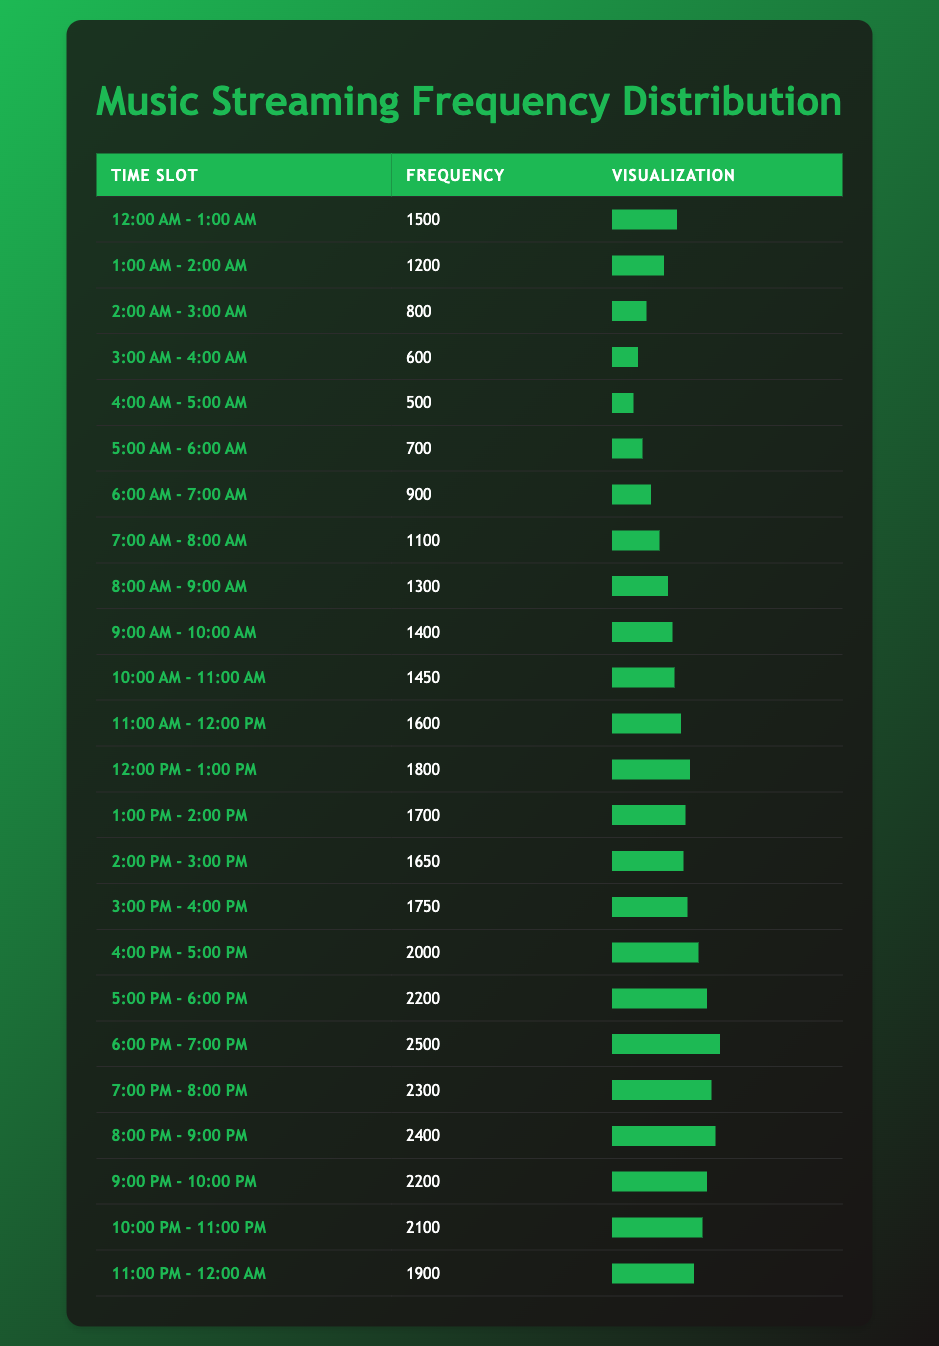What time slot had the highest frequency of streaming? By scanning the frequency data in the table, the time slot "6:00 PM - 7:00 PM" has the highest frequency with a value of 2500.
Answer: 6:00 PM - 7:00 PM What is the frequency of the time slot from 4:00 AM to 5:00 AM? In the table, the time slot "4:00 AM - 5:00 AM" shows a frequency of 500.
Answer: 500 What is the total frequency of streaming from 8:00 PM to 10:00 PM? First, we identify the frequencies in the time slots: "8:00 PM - 9:00 PM" has 2400, "9:00 PM - 10:00 PM" has 2200, and when we sum these values (2400 + 2200), we get 4600.
Answer: 4600 Is the frequency of the time slot from 10:00 PM to 11:00 PM greater than the frequency from 1:00 AM to 2:00 AM? The frequency for "10:00 PM - 11:00 PM" is 2100, and for "1:00 AM - 2:00 AM" it is 1200. Comparing these, 2100 is greater than 1200.
Answer: Yes What is the average frequency across the morning time slots from 12:00 AM to 12:00 PM? To find the average, I extract the frequencies from the relevant time slots: 1500, 1200, 800, 600, 500, 700, 900, 1100, 1300, 1400, 1450, 1600, 1800. I then sum these values, which equals 14050, and divide by the number of time slots (12) getting an average of approximately 1170.83.
Answer: 1170.83 Which time slot has a frequency between 600 and 800? The table shows that the time slot "3:00 AM - 4:00 AM" has a frequency of 600, and "2:00 AM - 3:00 AM" has a frequency of 800. Therefore, there is only one time slot that fits.
Answer: 3:00 AM - 4:00 AM How many more streams were there from the time slot 5:00 PM to 6:00 PM compared to the slot from 12:00 AM to 1:00 AM? From the table, the frequency for "5:00 PM - 6:00 PM" is 2200, and for "12:00 AM - 1:00 AM," it is 1500. The difference is calculated by subtracting the two rates: 2200 - 1500 = 700.
Answer: 700 What time slot comes before the one with the lowest frequency? The time slot with the lowest frequency is "4:00 AM - 5:00 AM" at 500. The preceding time slot is "3:00 AM - 4:00 AM," which has a frequency of 600.
Answer: 3:00 AM - 4:00 AM What is the frequency of streaming during lunchtime (12:00 PM to 1:00 PM)? Looking at the data in the table, the frequency for the time slot "12:00 PM - 1:00 PM" is 1800.
Answer: 1800 